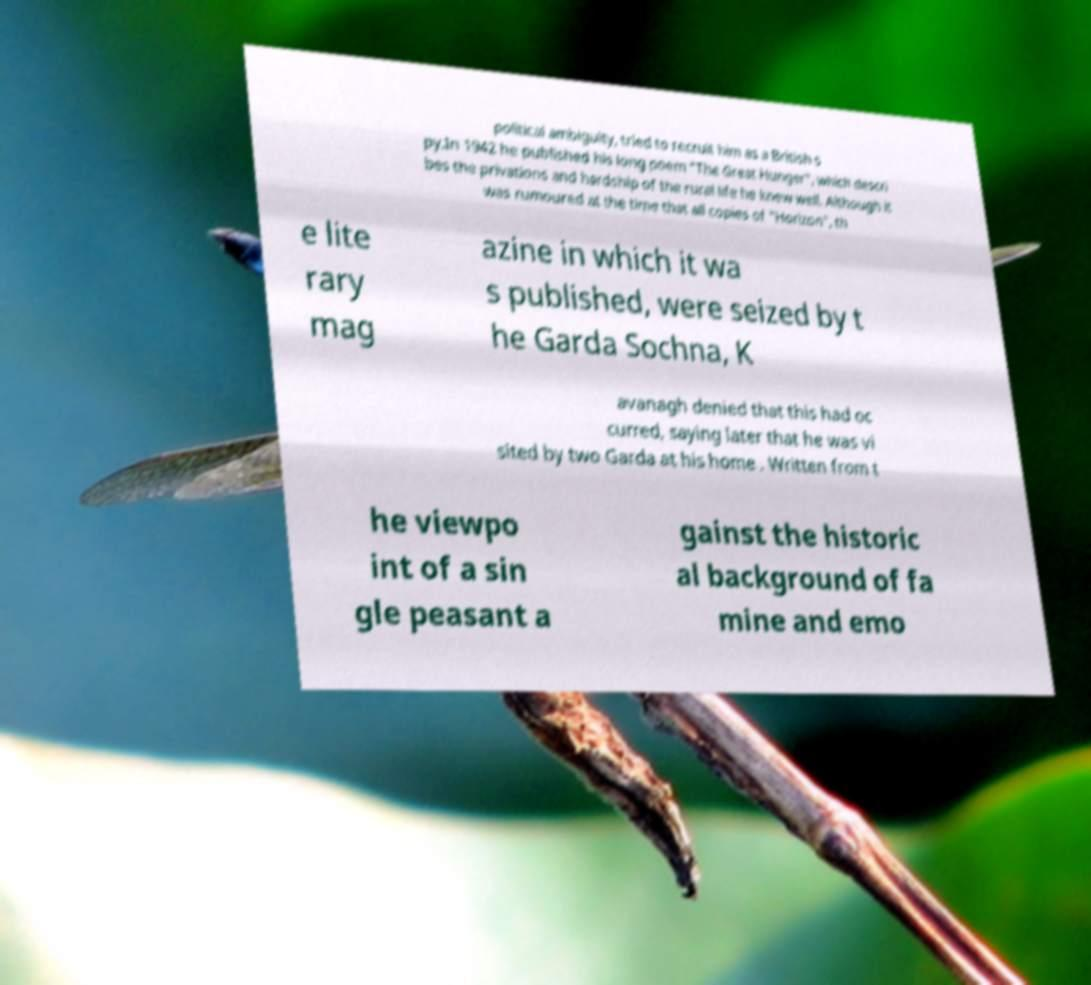Can you accurately transcribe the text from the provided image for me? political ambiguity, tried to recruit him as a British s py.In 1942 he published his long poem "The Great Hunger", which descri bes the privations and hardship of the rural life he knew well. Although it was rumoured at the time that all copies of "Horizon", th e lite rary mag azine in which it wa s published, were seized by t he Garda Sochna, K avanagh denied that this had oc curred, saying later that he was vi sited by two Garda at his home . Written from t he viewpo int of a sin gle peasant a gainst the historic al background of fa mine and emo 